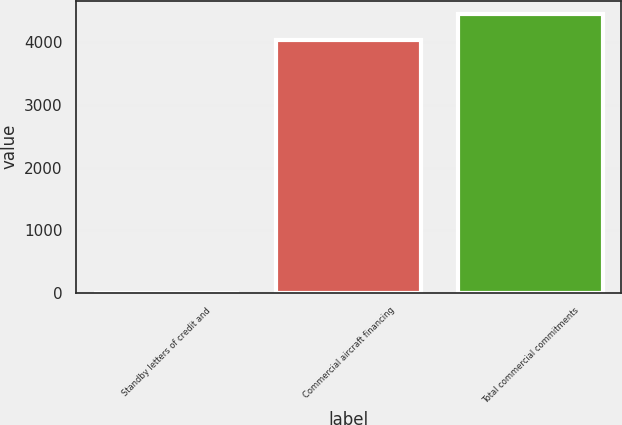<chart> <loc_0><loc_0><loc_500><loc_500><bar_chart><fcel>Standby letters of credit and<fcel>Commercial aircraft financing<fcel>Total commercial commitments<nl><fcel>1<fcel>4043<fcel>4447.3<nl></chart> 